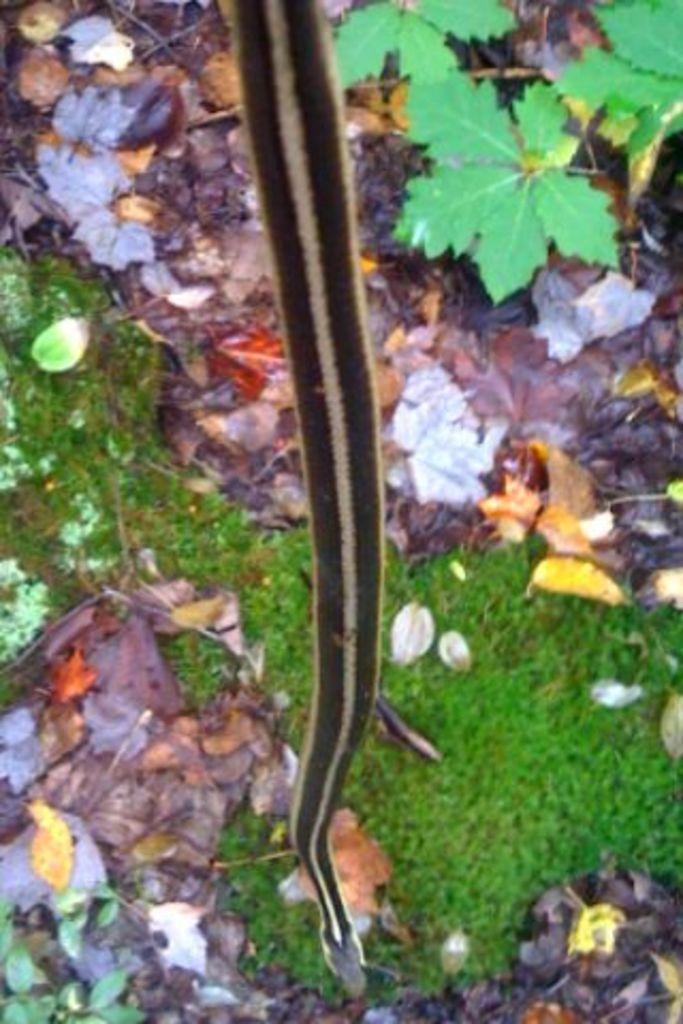In one or two sentences, can you explain what this image depicts? In this picture I can see there is a snake and there is grass, plants and dry leaves on the floor. 